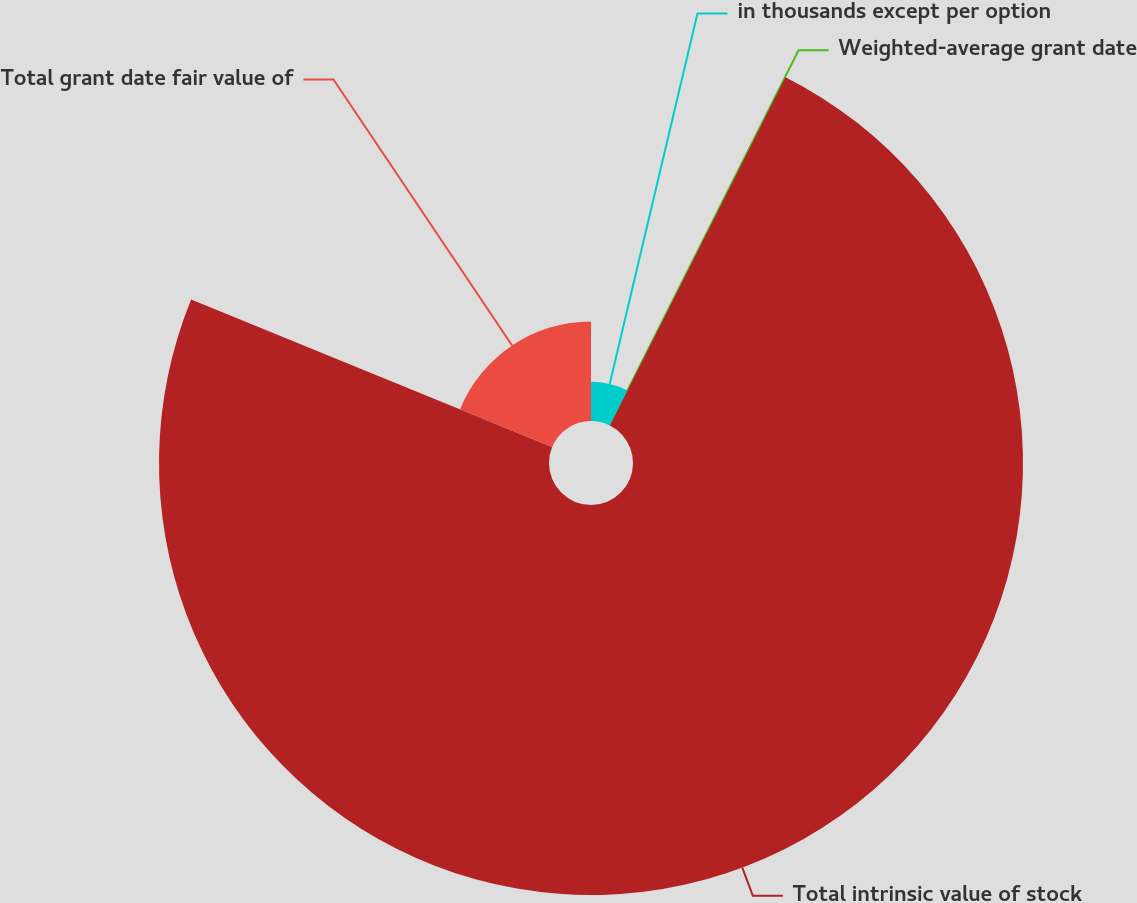<chart> <loc_0><loc_0><loc_500><loc_500><pie_chart><fcel>in thousands except per option<fcel>Weighted-average grant date<fcel>Total intrinsic value of stock<fcel>Total grant date fair value of<nl><fcel>7.4%<fcel>0.03%<fcel>73.74%<fcel>18.82%<nl></chart> 